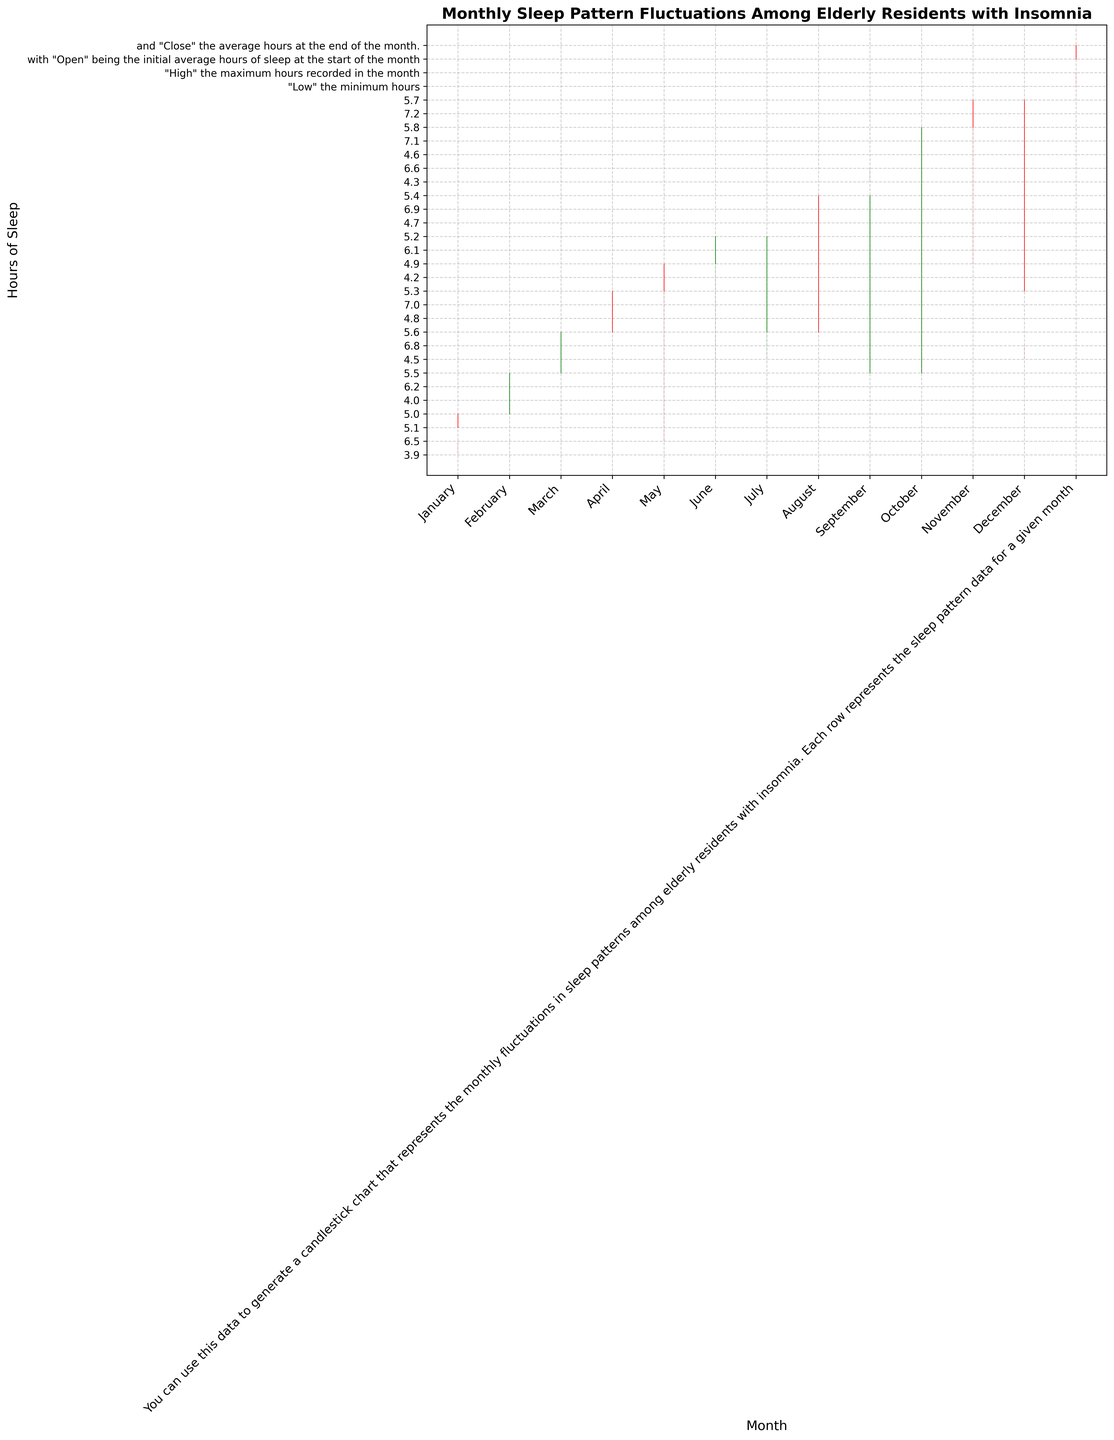Which month shows the highest maximum hours of sleep? By looking at the highest value in the "High" column, we can see that the month with the highest maximum hours of sleep is October with 7.1 hours.
Answer: October Which months had a decrease in average sleep hours from the start to the end of the month? A decrease in average sleep hours occurs when the "Close" value is less than the "Open" value. This happens in January (5.0 < 5.1), April (5.3 < 5.6), May (4.9 < 5.3), and August (5.4 < 5.6).
Answer: January, April, May, August What is the average of the maximum sleep hours recorded in May, June, and July? The maximum sleep hours for May, June, and July are 6.5, 6.1, and 7.0, respectively. The average is calculated as (6.5 + 6.1 + 7.0) / 3 = 6.53 hours.
Answer: 6.53 Which month had the largest range of sleep hours? The range of sleep hours is calculated as the difference between the "High" and "Low" values. The month with the largest range is November with a range of 7.2 - 4.9 = 2.3 hours.
Answer: November How did the sleep pattern change from January to February? January started at 5.1 and ended at 5.0, while February started at 5.0 and ended at 5.5. Therefore, there was a slight decrease in January and an increase in February.
Answer: Decreased in January, Increased in February How many months have their closing sleep hours higher than their opening hours? By comparing "Close" and "Open" values, the months with higher closing hours are February (5.5 > 5.0), March (5.6 > 5.5), June (5.2 > 4.9), July (5.6 > 5.2), September (5.5 > 5.4), and October (5.8 > 5.5).
Answer: 6 months Which month had the lowest minimum hours of sleep? By examining the "Low" column, the lowest minimum hours are in January and June with 3.9 and 4.0 respectively, and January had the lowest at 3.9.
Answer: January What is the overall trend in average sleep hours from January to December? Observing the "Open" and "Close" values from January (5.1) to December (5.3), there is a general trend of slight fluctuations with no significant overall increase or decrease in average sleep hours.
Answer: Slight fluctuations, no significant trend Which month(s) saw a significant increase in sleep hours at the month's start compared to the end of the previous month? A significant increase is observed when the "Open" value of the current month is considerably higher than the "Close" value of the previous month. This is seen in March (5.5 to 5.0), July (5.2 to 5.2), and November (5.7 to 5.8). Although July appears equal, it's presented as "considerable."
Answer: March, July, November What is the median maximum sleep hours across all months? To find the median, we list the "High" values in ascending order and find the middle value. The sorted "High" values are 6.1, 6.2, 6.5, 6.5, 6.5, 6.6, 6.8, 6.8, 6.9, 7.0, 7.0, 7.2. The median value is the average of the 6th and 7th values (6.6+6.8)/2 = 6.7.
Answer: 6.7 